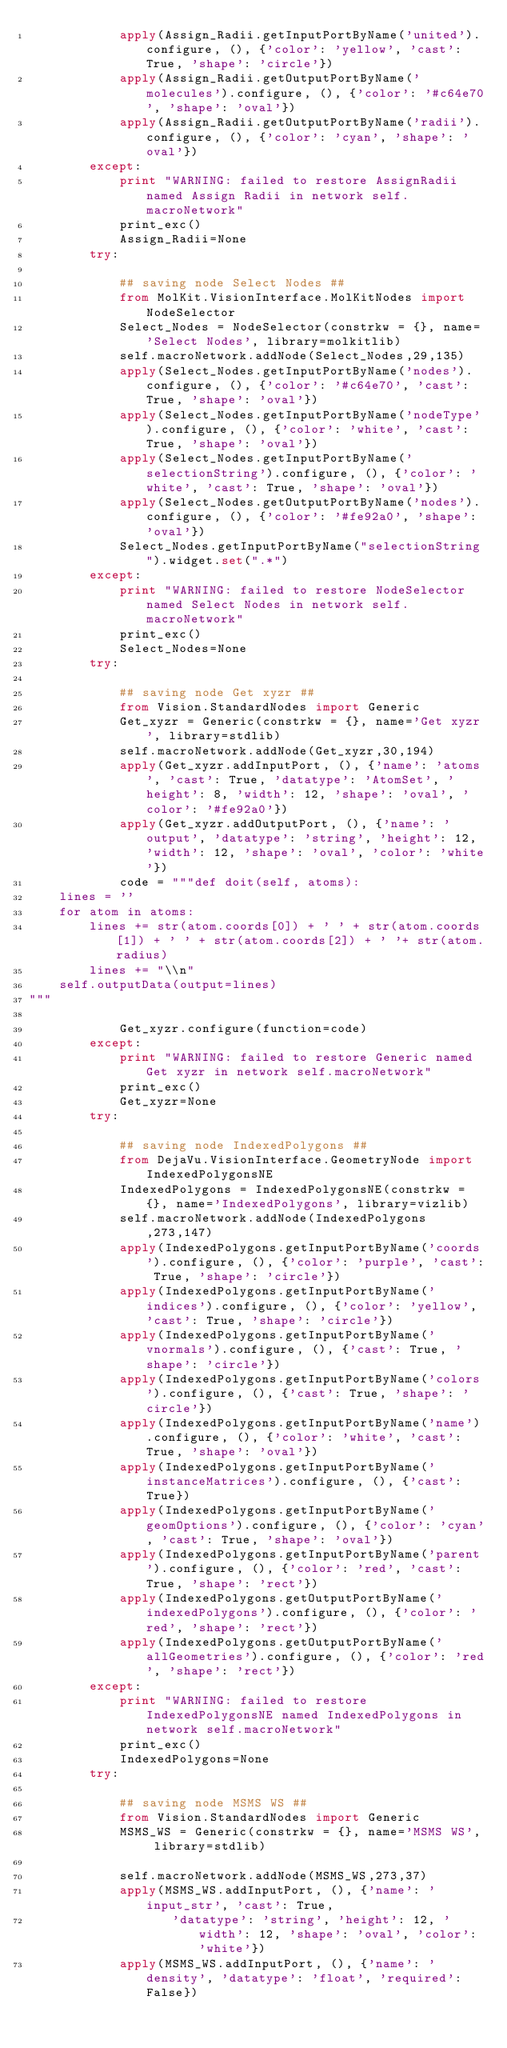<code> <loc_0><loc_0><loc_500><loc_500><_Python_>            apply(Assign_Radii.getInputPortByName('united').configure, (), {'color': 'yellow', 'cast': True, 'shape': 'circle'})
            apply(Assign_Radii.getOutputPortByName('molecules').configure, (), {'color': '#c64e70', 'shape': 'oval'})
            apply(Assign_Radii.getOutputPortByName('radii').configure, (), {'color': 'cyan', 'shape': 'oval'})
        except:
            print "WARNING: failed to restore AssignRadii named Assign Radii in network self.macroNetwork"
            print_exc()
            Assign_Radii=None
        try:

            ## saving node Select Nodes ##
            from MolKit.VisionInterface.MolKitNodes import NodeSelector
            Select_Nodes = NodeSelector(constrkw = {}, name='Select Nodes', library=molkitlib)
            self.macroNetwork.addNode(Select_Nodes,29,135)
            apply(Select_Nodes.getInputPortByName('nodes').configure, (), {'color': '#c64e70', 'cast': True, 'shape': 'oval'})
            apply(Select_Nodes.getInputPortByName('nodeType').configure, (), {'color': 'white', 'cast': True, 'shape': 'oval'})
            apply(Select_Nodes.getInputPortByName('selectionString').configure, (), {'color': 'white', 'cast': True, 'shape': 'oval'})
            apply(Select_Nodes.getOutputPortByName('nodes').configure, (), {'color': '#fe92a0', 'shape': 'oval'})
            Select_Nodes.getInputPortByName("selectionString").widget.set(".*")
        except:
            print "WARNING: failed to restore NodeSelector named Select Nodes in network self.macroNetwork"
            print_exc()
            Select_Nodes=None
        try:

            ## saving node Get xyzr ##
            from Vision.StandardNodes import Generic
            Get_xyzr = Generic(constrkw = {}, name='Get xyzr', library=stdlib)
            self.macroNetwork.addNode(Get_xyzr,30,194)
            apply(Get_xyzr.addInputPort, (), {'name': 'atoms', 'cast': True, 'datatype': 'AtomSet', 'height': 8, 'width': 12, 'shape': 'oval', 'color': '#fe92a0'})
            apply(Get_xyzr.addOutputPort, (), {'name': 'output', 'datatype': 'string', 'height': 12, 'width': 12, 'shape': 'oval', 'color': 'white'})
            code = """def doit(self, atoms):
    lines = ''
    for atom in atoms:
        lines += str(atom.coords[0]) + ' ' + str(atom.coords[1]) + ' ' + str(atom.coords[2]) + ' '+ str(atom.radius)
        lines += "\\n"
    self.outputData(output=lines)
"""

            Get_xyzr.configure(function=code)
        except:
            print "WARNING: failed to restore Generic named Get xyzr in network self.macroNetwork"
            print_exc()
            Get_xyzr=None
        try:

            ## saving node IndexedPolygons ##
            from DejaVu.VisionInterface.GeometryNode import IndexedPolygonsNE
            IndexedPolygons = IndexedPolygonsNE(constrkw = {}, name='IndexedPolygons', library=vizlib)
            self.macroNetwork.addNode(IndexedPolygons,273,147)
            apply(IndexedPolygons.getInputPortByName('coords').configure, (), {'color': 'purple', 'cast': True, 'shape': 'circle'})
            apply(IndexedPolygons.getInputPortByName('indices').configure, (), {'color': 'yellow', 'cast': True, 'shape': 'circle'})
            apply(IndexedPolygons.getInputPortByName('vnormals').configure, (), {'cast': True, 'shape': 'circle'})
            apply(IndexedPolygons.getInputPortByName('colors').configure, (), {'cast': True, 'shape': 'circle'})
            apply(IndexedPolygons.getInputPortByName('name').configure, (), {'color': 'white', 'cast': True, 'shape': 'oval'})
            apply(IndexedPolygons.getInputPortByName('instanceMatrices').configure, (), {'cast': True})
            apply(IndexedPolygons.getInputPortByName('geomOptions').configure, (), {'color': 'cyan', 'cast': True, 'shape': 'oval'})
            apply(IndexedPolygons.getInputPortByName('parent').configure, (), {'color': 'red', 'cast': True, 'shape': 'rect'})
            apply(IndexedPolygons.getOutputPortByName('indexedPolygons').configure, (), {'color': 'red', 'shape': 'rect'})
            apply(IndexedPolygons.getOutputPortByName('allGeometries').configure, (), {'color': 'red', 'shape': 'rect'})
        except:
            print "WARNING: failed to restore IndexedPolygonsNE named IndexedPolygons in network self.macroNetwork"
            print_exc()
            IndexedPolygons=None
        try:

            ## saving node MSMS WS ##
            from Vision.StandardNodes import Generic
            MSMS_WS = Generic(constrkw = {}, name='MSMS WS', library=stdlib)            

            self.macroNetwork.addNode(MSMS_WS,273,37)
            apply(MSMS_WS.addInputPort, (), {'name': 'input_str', 'cast': True, 
                   'datatype': 'string', 'height': 12, 'width': 12, 'shape': 'oval', 'color': 'white'})
            apply(MSMS_WS.addInputPort, (), {'name': 'density', 'datatype': 'float', 'required':False})</code> 